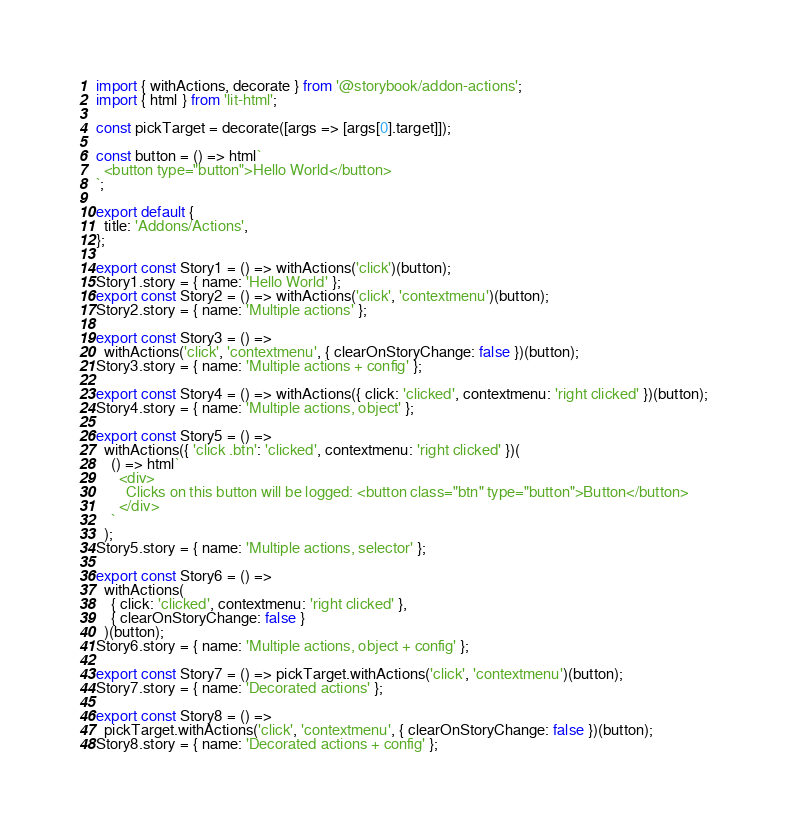<code> <loc_0><loc_0><loc_500><loc_500><_JavaScript_>import { withActions, decorate } from '@storybook/addon-actions';
import { html } from 'lit-html';

const pickTarget = decorate([args => [args[0].target]]);

const button = () => html`
  <button type="button">Hello World</button>
`;

export default {
  title: 'Addons/Actions',
};

export const Story1 = () => withActions('click')(button);
Story1.story = { name: 'Hello World' };
export const Story2 = () => withActions('click', 'contextmenu')(button);
Story2.story = { name: 'Multiple actions' };

export const Story3 = () =>
  withActions('click', 'contextmenu', { clearOnStoryChange: false })(button);
Story3.story = { name: 'Multiple actions + config' };

export const Story4 = () => withActions({ click: 'clicked', contextmenu: 'right clicked' })(button);
Story4.story = { name: 'Multiple actions, object' };

export const Story5 = () =>
  withActions({ 'click .btn': 'clicked', contextmenu: 'right clicked' })(
    () => html`
      <div>
        Clicks on this button will be logged: <button class="btn" type="button">Button</button>
      </div>
    `
  );
Story5.story = { name: 'Multiple actions, selector' };

export const Story6 = () =>
  withActions(
    { click: 'clicked', contextmenu: 'right clicked' },
    { clearOnStoryChange: false }
  )(button);
Story6.story = { name: 'Multiple actions, object + config' };

export const Story7 = () => pickTarget.withActions('click', 'contextmenu')(button);
Story7.story = { name: 'Decorated actions' };

export const Story8 = () =>
  pickTarget.withActions('click', 'contextmenu', { clearOnStoryChange: false })(button);
Story8.story = { name: 'Decorated actions + config' };
</code> 